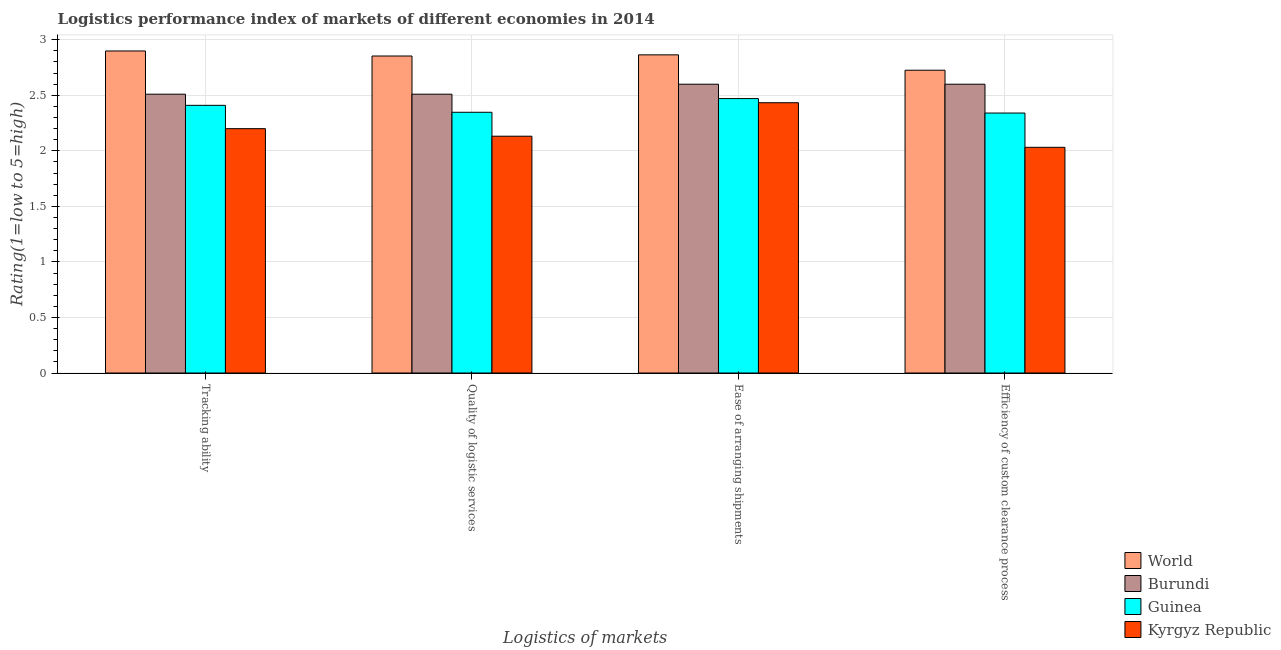How many groups of bars are there?
Ensure brevity in your answer.  4. Are the number of bars on each tick of the X-axis equal?
Your answer should be very brief. Yes. How many bars are there on the 4th tick from the left?
Provide a short and direct response. 4. How many bars are there on the 3rd tick from the right?
Your answer should be very brief. 4. What is the label of the 3rd group of bars from the left?
Ensure brevity in your answer.  Ease of arranging shipments. What is the lpi rating of efficiency of custom clearance process in Burundi?
Give a very brief answer. 2.6. Across all countries, what is the maximum lpi rating of quality of logistic services?
Provide a succinct answer. 2.85. Across all countries, what is the minimum lpi rating of tracking ability?
Offer a terse response. 2.2. In which country was the lpi rating of quality of logistic services minimum?
Provide a succinct answer. Kyrgyz Republic. What is the total lpi rating of ease of arranging shipments in the graph?
Offer a terse response. 10.37. What is the difference between the lpi rating of efficiency of custom clearance process in Guinea and that in World?
Your answer should be very brief. -0.39. What is the difference between the lpi rating of tracking ability in Guinea and the lpi rating of quality of logistic services in Burundi?
Your response must be concise. -0.1. What is the average lpi rating of quality of logistic services per country?
Ensure brevity in your answer.  2.46. What is the difference between the lpi rating of tracking ability and lpi rating of ease of arranging shipments in Guinea?
Provide a short and direct response. -0.06. What is the ratio of the lpi rating of quality of logistic services in Kyrgyz Republic to that in Guinea?
Keep it short and to the point. 0.91. What is the difference between the highest and the second highest lpi rating of tracking ability?
Keep it short and to the point. 0.39. What is the difference between the highest and the lowest lpi rating of ease of arranging shipments?
Keep it short and to the point. 0.43. Is it the case that in every country, the sum of the lpi rating of tracking ability and lpi rating of efficiency of custom clearance process is greater than the sum of lpi rating of ease of arranging shipments and lpi rating of quality of logistic services?
Provide a succinct answer. No. What does the 3rd bar from the left in Quality of logistic services represents?
Offer a very short reply. Guinea. What does the 2nd bar from the right in Ease of arranging shipments represents?
Ensure brevity in your answer.  Guinea. How many bars are there?
Your answer should be compact. 16. Are all the bars in the graph horizontal?
Provide a short and direct response. No. Are the values on the major ticks of Y-axis written in scientific E-notation?
Ensure brevity in your answer.  No. Does the graph contain any zero values?
Your answer should be compact. No. Where does the legend appear in the graph?
Your answer should be very brief. Bottom right. What is the title of the graph?
Provide a succinct answer. Logistics performance index of markets of different economies in 2014. Does "Switzerland" appear as one of the legend labels in the graph?
Offer a terse response. No. What is the label or title of the X-axis?
Your answer should be very brief. Logistics of markets. What is the label or title of the Y-axis?
Offer a terse response. Rating(1=low to 5=high). What is the Rating(1=low to 5=high) in World in Tracking ability?
Give a very brief answer. 2.9. What is the Rating(1=low to 5=high) of Burundi in Tracking ability?
Your response must be concise. 2.51. What is the Rating(1=low to 5=high) of Guinea in Tracking ability?
Keep it short and to the point. 2.41. What is the Rating(1=low to 5=high) of Kyrgyz Republic in Tracking ability?
Keep it short and to the point. 2.2. What is the Rating(1=low to 5=high) in World in Quality of logistic services?
Offer a very short reply. 2.85. What is the Rating(1=low to 5=high) of Burundi in Quality of logistic services?
Provide a succinct answer. 2.51. What is the Rating(1=low to 5=high) in Guinea in Quality of logistic services?
Your answer should be compact. 2.35. What is the Rating(1=low to 5=high) in Kyrgyz Republic in Quality of logistic services?
Your response must be concise. 2.13. What is the Rating(1=low to 5=high) of World in Ease of arranging shipments?
Keep it short and to the point. 2.86. What is the Rating(1=low to 5=high) of Guinea in Ease of arranging shipments?
Give a very brief answer. 2.47. What is the Rating(1=low to 5=high) in Kyrgyz Republic in Ease of arranging shipments?
Provide a short and direct response. 2.43. What is the Rating(1=low to 5=high) in World in Efficiency of custom clearance process?
Offer a very short reply. 2.73. What is the Rating(1=low to 5=high) of Burundi in Efficiency of custom clearance process?
Offer a very short reply. 2.6. What is the Rating(1=low to 5=high) in Guinea in Efficiency of custom clearance process?
Provide a short and direct response. 2.34. What is the Rating(1=low to 5=high) in Kyrgyz Republic in Efficiency of custom clearance process?
Give a very brief answer. 2.03. Across all Logistics of markets, what is the maximum Rating(1=low to 5=high) of World?
Make the answer very short. 2.9. Across all Logistics of markets, what is the maximum Rating(1=low to 5=high) of Guinea?
Ensure brevity in your answer.  2.47. Across all Logistics of markets, what is the maximum Rating(1=low to 5=high) in Kyrgyz Republic?
Offer a very short reply. 2.43. Across all Logistics of markets, what is the minimum Rating(1=low to 5=high) in World?
Keep it short and to the point. 2.73. Across all Logistics of markets, what is the minimum Rating(1=low to 5=high) in Burundi?
Keep it short and to the point. 2.51. Across all Logistics of markets, what is the minimum Rating(1=low to 5=high) in Guinea?
Your response must be concise. 2.34. Across all Logistics of markets, what is the minimum Rating(1=low to 5=high) of Kyrgyz Republic?
Offer a terse response. 2.03. What is the total Rating(1=low to 5=high) of World in the graph?
Provide a short and direct response. 11.34. What is the total Rating(1=low to 5=high) of Burundi in the graph?
Your response must be concise. 10.22. What is the total Rating(1=low to 5=high) of Guinea in the graph?
Ensure brevity in your answer.  9.57. What is the total Rating(1=low to 5=high) of Kyrgyz Republic in the graph?
Give a very brief answer. 8.8. What is the difference between the Rating(1=low to 5=high) in World in Tracking ability and that in Quality of logistic services?
Keep it short and to the point. 0.05. What is the difference between the Rating(1=low to 5=high) of Burundi in Tracking ability and that in Quality of logistic services?
Your answer should be very brief. 0. What is the difference between the Rating(1=low to 5=high) of Guinea in Tracking ability and that in Quality of logistic services?
Make the answer very short. 0.06. What is the difference between the Rating(1=low to 5=high) of Kyrgyz Republic in Tracking ability and that in Quality of logistic services?
Give a very brief answer. 0.07. What is the difference between the Rating(1=low to 5=high) of World in Tracking ability and that in Ease of arranging shipments?
Provide a short and direct response. 0.03. What is the difference between the Rating(1=low to 5=high) in Burundi in Tracking ability and that in Ease of arranging shipments?
Your response must be concise. -0.09. What is the difference between the Rating(1=low to 5=high) in Guinea in Tracking ability and that in Ease of arranging shipments?
Your answer should be very brief. -0.06. What is the difference between the Rating(1=low to 5=high) in Kyrgyz Republic in Tracking ability and that in Ease of arranging shipments?
Provide a short and direct response. -0.23. What is the difference between the Rating(1=low to 5=high) in World in Tracking ability and that in Efficiency of custom clearance process?
Ensure brevity in your answer.  0.17. What is the difference between the Rating(1=low to 5=high) in Burundi in Tracking ability and that in Efficiency of custom clearance process?
Make the answer very short. -0.09. What is the difference between the Rating(1=low to 5=high) of Guinea in Tracking ability and that in Efficiency of custom clearance process?
Make the answer very short. 0.07. What is the difference between the Rating(1=low to 5=high) in Kyrgyz Republic in Tracking ability and that in Efficiency of custom clearance process?
Make the answer very short. 0.17. What is the difference between the Rating(1=low to 5=high) of World in Quality of logistic services and that in Ease of arranging shipments?
Your answer should be very brief. -0.01. What is the difference between the Rating(1=low to 5=high) of Burundi in Quality of logistic services and that in Ease of arranging shipments?
Your response must be concise. -0.09. What is the difference between the Rating(1=low to 5=high) in Guinea in Quality of logistic services and that in Ease of arranging shipments?
Make the answer very short. -0.12. What is the difference between the Rating(1=low to 5=high) of Kyrgyz Republic in Quality of logistic services and that in Ease of arranging shipments?
Your answer should be very brief. -0.3. What is the difference between the Rating(1=low to 5=high) in World in Quality of logistic services and that in Efficiency of custom clearance process?
Offer a terse response. 0.13. What is the difference between the Rating(1=low to 5=high) in Burundi in Quality of logistic services and that in Efficiency of custom clearance process?
Your response must be concise. -0.09. What is the difference between the Rating(1=low to 5=high) of Guinea in Quality of logistic services and that in Efficiency of custom clearance process?
Your response must be concise. 0.01. What is the difference between the Rating(1=low to 5=high) in World in Ease of arranging shipments and that in Efficiency of custom clearance process?
Offer a very short reply. 0.14. What is the difference between the Rating(1=low to 5=high) in Burundi in Ease of arranging shipments and that in Efficiency of custom clearance process?
Offer a very short reply. 0. What is the difference between the Rating(1=low to 5=high) in Guinea in Ease of arranging shipments and that in Efficiency of custom clearance process?
Your answer should be compact. 0.13. What is the difference between the Rating(1=low to 5=high) in Kyrgyz Republic in Ease of arranging shipments and that in Efficiency of custom clearance process?
Your response must be concise. 0.4. What is the difference between the Rating(1=low to 5=high) in World in Tracking ability and the Rating(1=low to 5=high) in Burundi in Quality of logistic services?
Keep it short and to the point. 0.39. What is the difference between the Rating(1=low to 5=high) in World in Tracking ability and the Rating(1=low to 5=high) in Guinea in Quality of logistic services?
Your response must be concise. 0.55. What is the difference between the Rating(1=low to 5=high) in World in Tracking ability and the Rating(1=low to 5=high) in Kyrgyz Republic in Quality of logistic services?
Provide a succinct answer. 0.77. What is the difference between the Rating(1=low to 5=high) in Burundi in Tracking ability and the Rating(1=low to 5=high) in Guinea in Quality of logistic services?
Ensure brevity in your answer.  0.16. What is the difference between the Rating(1=low to 5=high) of Burundi in Tracking ability and the Rating(1=low to 5=high) of Kyrgyz Republic in Quality of logistic services?
Offer a terse response. 0.38. What is the difference between the Rating(1=low to 5=high) of Guinea in Tracking ability and the Rating(1=low to 5=high) of Kyrgyz Republic in Quality of logistic services?
Provide a short and direct response. 0.28. What is the difference between the Rating(1=low to 5=high) in World in Tracking ability and the Rating(1=low to 5=high) in Burundi in Ease of arranging shipments?
Ensure brevity in your answer.  0.3. What is the difference between the Rating(1=low to 5=high) of World in Tracking ability and the Rating(1=low to 5=high) of Guinea in Ease of arranging shipments?
Provide a short and direct response. 0.43. What is the difference between the Rating(1=low to 5=high) in World in Tracking ability and the Rating(1=low to 5=high) in Kyrgyz Republic in Ease of arranging shipments?
Provide a short and direct response. 0.47. What is the difference between the Rating(1=low to 5=high) in Burundi in Tracking ability and the Rating(1=low to 5=high) in Guinea in Ease of arranging shipments?
Give a very brief answer. 0.04. What is the difference between the Rating(1=low to 5=high) of Burundi in Tracking ability and the Rating(1=low to 5=high) of Kyrgyz Republic in Ease of arranging shipments?
Your response must be concise. 0.08. What is the difference between the Rating(1=low to 5=high) in Guinea in Tracking ability and the Rating(1=low to 5=high) in Kyrgyz Republic in Ease of arranging shipments?
Provide a succinct answer. -0.02. What is the difference between the Rating(1=low to 5=high) of World in Tracking ability and the Rating(1=low to 5=high) of Burundi in Efficiency of custom clearance process?
Your response must be concise. 0.3. What is the difference between the Rating(1=low to 5=high) in World in Tracking ability and the Rating(1=low to 5=high) in Guinea in Efficiency of custom clearance process?
Your response must be concise. 0.56. What is the difference between the Rating(1=low to 5=high) of World in Tracking ability and the Rating(1=low to 5=high) of Kyrgyz Republic in Efficiency of custom clearance process?
Keep it short and to the point. 0.87. What is the difference between the Rating(1=low to 5=high) in Burundi in Tracking ability and the Rating(1=low to 5=high) in Guinea in Efficiency of custom clearance process?
Make the answer very short. 0.17. What is the difference between the Rating(1=low to 5=high) in Burundi in Tracking ability and the Rating(1=low to 5=high) in Kyrgyz Republic in Efficiency of custom clearance process?
Your answer should be very brief. 0.48. What is the difference between the Rating(1=low to 5=high) in Guinea in Tracking ability and the Rating(1=low to 5=high) in Kyrgyz Republic in Efficiency of custom clearance process?
Offer a terse response. 0.38. What is the difference between the Rating(1=low to 5=high) of World in Quality of logistic services and the Rating(1=low to 5=high) of Burundi in Ease of arranging shipments?
Offer a very short reply. 0.25. What is the difference between the Rating(1=low to 5=high) in World in Quality of logistic services and the Rating(1=low to 5=high) in Guinea in Ease of arranging shipments?
Offer a terse response. 0.38. What is the difference between the Rating(1=low to 5=high) in World in Quality of logistic services and the Rating(1=low to 5=high) in Kyrgyz Republic in Ease of arranging shipments?
Give a very brief answer. 0.42. What is the difference between the Rating(1=low to 5=high) in Burundi in Quality of logistic services and the Rating(1=low to 5=high) in Guinea in Ease of arranging shipments?
Offer a terse response. 0.04. What is the difference between the Rating(1=low to 5=high) in Burundi in Quality of logistic services and the Rating(1=low to 5=high) in Kyrgyz Republic in Ease of arranging shipments?
Offer a very short reply. 0.08. What is the difference between the Rating(1=low to 5=high) in Guinea in Quality of logistic services and the Rating(1=low to 5=high) in Kyrgyz Republic in Ease of arranging shipments?
Offer a terse response. -0.09. What is the difference between the Rating(1=low to 5=high) of World in Quality of logistic services and the Rating(1=low to 5=high) of Burundi in Efficiency of custom clearance process?
Your answer should be very brief. 0.25. What is the difference between the Rating(1=low to 5=high) in World in Quality of logistic services and the Rating(1=low to 5=high) in Guinea in Efficiency of custom clearance process?
Keep it short and to the point. 0.51. What is the difference between the Rating(1=low to 5=high) of World in Quality of logistic services and the Rating(1=low to 5=high) of Kyrgyz Republic in Efficiency of custom clearance process?
Ensure brevity in your answer.  0.82. What is the difference between the Rating(1=low to 5=high) of Burundi in Quality of logistic services and the Rating(1=low to 5=high) of Guinea in Efficiency of custom clearance process?
Your response must be concise. 0.17. What is the difference between the Rating(1=low to 5=high) in Burundi in Quality of logistic services and the Rating(1=low to 5=high) in Kyrgyz Republic in Efficiency of custom clearance process?
Your response must be concise. 0.48. What is the difference between the Rating(1=low to 5=high) of Guinea in Quality of logistic services and the Rating(1=low to 5=high) of Kyrgyz Republic in Efficiency of custom clearance process?
Give a very brief answer. 0.32. What is the difference between the Rating(1=low to 5=high) in World in Ease of arranging shipments and the Rating(1=low to 5=high) in Burundi in Efficiency of custom clearance process?
Give a very brief answer. 0.26. What is the difference between the Rating(1=low to 5=high) of World in Ease of arranging shipments and the Rating(1=low to 5=high) of Guinea in Efficiency of custom clearance process?
Ensure brevity in your answer.  0.52. What is the difference between the Rating(1=low to 5=high) of World in Ease of arranging shipments and the Rating(1=low to 5=high) of Kyrgyz Republic in Efficiency of custom clearance process?
Offer a terse response. 0.83. What is the difference between the Rating(1=low to 5=high) of Burundi in Ease of arranging shipments and the Rating(1=low to 5=high) of Guinea in Efficiency of custom clearance process?
Keep it short and to the point. 0.26. What is the difference between the Rating(1=low to 5=high) of Burundi in Ease of arranging shipments and the Rating(1=low to 5=high) of Kyrgyz Republic in Efficiency of custom clearance process?
Give a very brief answer. 0.57. What is the difference between the Rating(1=low to 5=high) of Guinea in Ease of arranging shipments and the Rating(1=low to 5=high) of Kyrgyz Republic in Efficiency of custom clearance process?
Keep it short and to the point. 0.44. What is the average Rating(1=low to 5=high) in World per Logistics of markets?
Your answer should be very brief. 2.84. What is the average Rating(1=low to 5=high) of Burundi per Logistics of markets?
Keep it short and to the point. 2.56. What is the average Rating(1=low to 5=high) in Guinea per Logistics of markets?
Ensure brevity in your answer.  2.39. What is the average Rating(1=low to 5=high) in Kyrgyz Republic per Logistics of markets?
Give a very brief answer. 2.2. What is the difference between the Rating(1=low to 5=high) of World and Rating(1=low to 5=high) of Burundi in Tracking ability?
Your response must be concise. 0.39. What is the difference between the Rating(1=low to 5=high) in World and Rating(1=low to 5=high) in Guinea in Tracking ability?
Your response must be concise. 0.49. What is the difference between the Rating(1=low to 5=high) in World and Rating(1=low to 5=high) in Kyrgyz Republic in Tracking ability?
Offer a very short reply. 0.7. What is the difference between the Rating(1=low to 5=high) in Burundi and Rating(1=low to 5=high) in Guinea in Tracking ability?
Your response must be concise. 0.1. What is the difference between the Rating(1=low to 5=high) of Burundi and Rating(1=low to 5=high) of Kyrgyz Republic in Tracking ability?
Keep it short and to the point. 0.31. What is the difference between the Rating(1=low to 5=high) in Guinea and Rating(1=low to 5=high) in Kyrgyz Republic in Tracking ability?
Ensure brevity in your answer.  0.21. What is the difference between the Rating(1=low to 5=high) in World and Rating(1=low to 5=high) in Burundi in Quality of logistic services?
Make the answer very short. 0.34. What is the difference between the Rating(1=low to 5=high) of World and Rating(1=low to 5=high) of Guinea in Quality of logistic services?
Offer a very short reply. 0.51. What is the difference between the Rating(1=low to 5=high) in World and Rating(1=low to 5=high) in Kyrgyz Republic in Quality of logistic services?
Make the answer very short. 0.72. What is the difference between the Rating(1=low to 5=high) in Burundi and Rating(1=low to 5=high) in Guinea in Quality of logistic services?
Offer a very short reply. 0.16. What is the difference between the Rating(1=low to 5=high) in Burundi and Rating(1=low to 5=high) in Kyrgyz Republic in Quality of logistic services?
Give a very brief answer. 0.38. What is the difference between the Rating(1=low to 5=high) in Guinea and Rating(1=low to 5=high) in Kyrgyz Republic in Quality of logistic services?
Your response must be concise. 0.22. What is the difference between the Rating(1=low to 5=high) of World and Rating(1=low to 5=high) of Burundi in Ease of arranging shipments?
Give a very brief answer. 0.26. What is the difference between the Rating(1=low to 5=high) in World and Rating(1=low to 5=high) in Guinea in Ease of arranging shipments?
Keep it short and to the point. 0.39. What is the difference between the Rating(1=low to 5=high) of World and Rating(1=low to 5=high) of Kyrgyz Republic in Ease of arranging shipments?
Keep it short and to the point. 0.43. What is the difference between the Rating(1=low to 5=high) of Burundi and Rating(1=low to 5=high) of Guinea in Ease of arranging shipments?
Provide a short and direct response. 0.13. What is the difference between the Rating(1=low to 5=high) of Guinea and Rating(1=low to 5=high) of Kyrgyz Republic in Ease of arranging shipments?
Your response must be concise. 0.04. What is the difference between the Rating(1=low to 5=high) in World and Rating(1=low to 5=high) in Burundi in Efficiency of custom clearance process?
Your response must be concise. 0.13. What is the difference between the Rating(1=low to 5=high) of World and Rating(1=low to 5=high) of Guinea in Efficiency of custom clearance process?
Provide a short and direct response. 0.39. What is the difference between the Rating(1=low to 5=high) of World and Rating(1=low to 5=high) of Kyrgyz Republic in Efficiency of custom clearance process?
Your answer should be very brief. 0.69. What is the difference between the Rating(1=low to 5=high) in Burundi and Rating(1=low to 5=high) in Guinea in Efficiency of custom clearance process?
Offer a terse response. 0.26. What is the difference between the Rating(1=low to 5=high) in Burundi and Rating(1=low to 5=high) in Kyrgyz Republic in Efficiency of custom clearance process?
Your answer should be compact. 0.57. What is the difference between the Rating(1=low to 5=high) in Guinea and Rating(1=low to 5=high) in Kyrgyz Republic in Efficiency of custom clearance process?
Your answer should be very brief. 0.31. What is the ratio of the Rating(1=low to 5=high) in World in Tracking ability to that in Quality of logistic services?
Keep it short and to the point. 1.02. What is the ratio of the Rating(1=low to 5=high) of Guinea in Tracking ability to that in Quality of logistic services?
Ensure brevity in your answer.  1.03. What is the ratio of the Rating(1=low to 5=high) in Kyrgyz Republic in Tracking ability to that in Quality of logistic services?
Provide a short and direct response. 1.03. What is the ratio of the Rating(1=low to 5=high) in World in Tracking ability to that in Ease of arranging shipments?
Ensure brevity in your answer.  1.01. What is the ratio of the Rating(1=low to 5=high) in Burundi in Tracking ability to that in Ease of arranging shipments?
Provide a short and direct response. 0.97. What is the ratio of the Rating(1=low to 5=high) in Guinea in Tracking ability to that in Ease of arranging shipments?
Keep it short and to the point. 0.98. What is the ratio of the Rating(1=low to 5=high) in Kyrgyz Republic in Tracking ability to that in Ease of arranging shipments?
Ensure brevity in your answer.  0.9. What is the ratio of the Rating(1=low to 5=high) of World in Tracking ability to that in Efficiency of custom clearance process?
Provide a short and direct response. 1.06. What is the ratio of the Rating(1=low to 5=high) of Burundi in Tracking ability to that in Efficiency of custom clearance process?
Your response must be concise. 0.97. What is the ratio of the Rating(1=low to 5=high) of Guinea in Tracking ability to that in Efficiency of custom clearance process?
Give a very brief answer. 1.03. What is the ratio of the Rating(1=low to 5=high) of Kyrgyz Republic in Tracking ability to that in Efficiency of custom clearance process?
Offer a very short reply. 1.08. What is the ratio of the Rating(1=low to 5=high) of Burundi in Quality of logistic services to that in Ease of arranging shipments?
Your answer should be compact. 0.97. What is the ratio of the Rating(1=low to 5=high) of Guinea in Quality of logistic services to that in Ease of arranging shipments?
Provide a succinct answer. 0.95. What is the ratio of the Rating(1=low to 5=high) in Kyrgyz Republic in Quality of logistic services to that in Ease of arranging shipments?
Give a very brief answer. 0.88. What is the ratio of the Rating(1=low to 5=high) of World in Quality of logistic services to that in Efficiency of custom clearance process?
Provide a short and direct response. 1.05. What is the ratio of the Rating(1=low to 5=high) in Burundi in Quality of logistic services to that in Efficiency of custom clearance process?
Your response must be concise. 0.97. What is the ratio of the Rating(1=low to 5=high) in Kyrgyz Republic in Quality of logistic services to that in Efficiency of custom clearance process?
Your answer should be compact. 1.05. What is the ratio of the Rating(1=low to 5=high) of World in Ease of arranging shipments to that in Efficiency of custom clearance process?
Make the answer very short. 1.05. What is the ratio of the Rating(1=low to 5=high) in Burundi in Ease of arranging shipments to that in Efficiency of custom clearance process?
Offer a terse response. 1. What is the ratio of the Rating(1=low to 5=high) of Guinea in Ease of arranging shipments to that in Efficiency of custom clearance process?
Offer a very short reply. 1.06. What is the ratio of the Rating(1=low to 5=high) of Kyrgyz Republic in Ease of arranging shipments to that in Efficiency of custom clearance process?
Your response must be concise. 1.2. What is the difference between the highest and the second highest Rating(1=low to 5=high) in World?
Offer a terse response. 0.03. What is the difference between the highest and the second highest Rating(1=low to 5=high) in Guinea?
Your answer should be very brief. 0.06. What is the difference between the highest and the second highest Rating(1=low to 5=high) of Kyrgyz Republic?
Your answer should be very brief. 0.23. What is the difference between the highest and the lowest Rating(1=low to 5=high) of World?
Ensure brevity in your answer.  0.17. What is the difference between the highest and the lowest Rating(1=low to 5=high) in Burundi?
Offer a terse response. 0.09. What is the difference between the highest and the lowest Rating(1=low to 5=high) of Guinea?
Keep it short and to the point. 0.13. What is the difference between the highest and the lowest Rating(1=low to 5=high) in Kyrgyz Republic?
Provide a short and direct response. 0.4. 